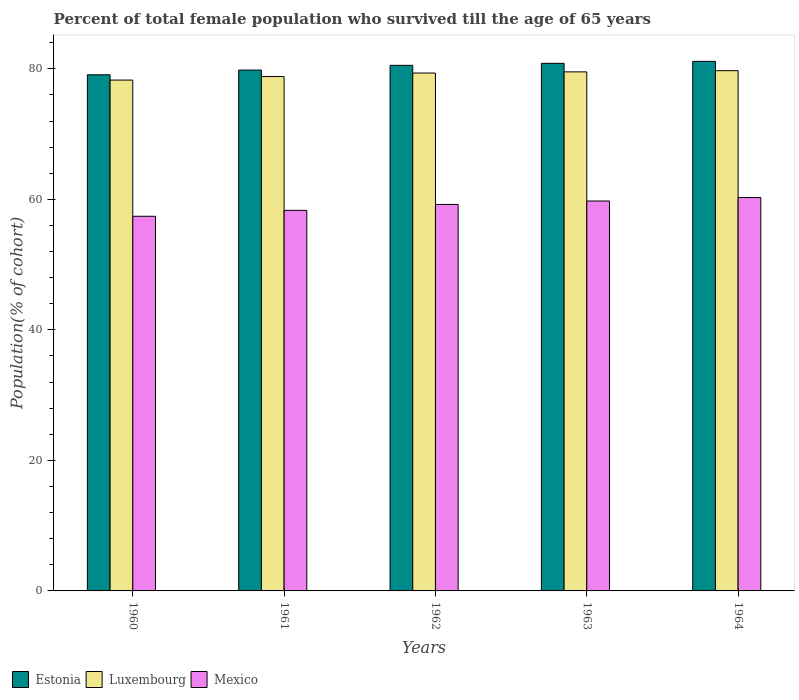Are the number of bars on each tick of the X-axis equal?
Provide a short and direct response. Yes. How many bars are there on the 1st tick from the left?
Provide a short and direct response. 3. How many bars are there on the 1st tick from the right?
Offer a terse response. 3. What is the label of the 1st group of bars from the left?
Your answer should be very brief. 1960. In how many cases, is the number of bars for a given year not equal to the number of legend labels?
Your response must be concise. 0. What is the percentage of total female population who survived till the age of 65 years in Mexico in 1964?
Give a very brief answer. 60.27. Across all years, what is the maximum percentage of total female population who survived till the age of 65 years in Mexico?
Your answer should be very brief. 60.27. Across all years, what is the minimum percentage of total female population who survived till the age of 65 years in Luxembourg?
Keep it short and to the point. 78.27. In which year was the percentage of total female population who survived till the age of 65 years in Estonia maximum?
Provide a short and direct response. 1964. What is the total percentage of total female population who survived till the age of 65 years in Estonia in the graph?
Offer a terse response. 401.4. What is the difference between the percentage of total female population who survived till the age of 65 years in Luxembourg in 1961 and that in 1963?
Keep it short and to the point. -0.72. What is the difference between the percentage of total female population who survived till the age of 65 years in Estonia in 1963 and the percentage of total female population who survived till the age of 65 years in Luxembourg in 1961?
Your response must be concise. 2.03. What is the average percentage of total female population who survived till the age of 65 years in Estonia per year?
Make the answer very short. 80.28. In the year 1961, what is the difference between the percentage of total female population who survived till the age of 65 years in Estonia and percentage of total female population who survived till the age of 65 years in Mexico?
Provide a succinct answer. 21.5. In how many years, is the percentage of total female population who survived till the age of 65 years in Mexico greater than 24 %?
Give a very brief answer. 5. What is the ratio of the percentage of total female population who survived till the age of 65 years in Estonia in 1960 to that in 1961?
Provide a short and direct response. 0.99. What is the difference between the highest and the second highest percentage of total female population who survived till the age of 65 years in Mexico?
Offer a terse response. 0.53. What is the difference between the highest and the lowest percentage of total female population who survived till the age of 65 years in Estonia?
Give a very brief answer. 2.06. Is the sum of the percentage of total female population who survived till the age of 65 years in Estonia in 1960 and 1962 greater than the maximum percentage of total female population who survived till the age of 65 years in Mexico across all years?
Your response must be concise. Yes. What does the 2nd bar from the left in 1961 represents?
Provide a short and direct response. Luxembourg. What does the 3rd bar from the right in 1960 represents?
Provide a short and direct response. Estonia. How many bars are there?
Make the answer very short. 15. How many years are there in the graph?
Ensure brevity in your answer.  5. Are the values on the major ticks of Y-axis written in scientific E-notation?
Your answer should be very brief. No. Does the graph contain grids?
Provide a succinct answer. No. Where does the legend appear in the graph?
Offer a terse response. Bottom left. How many legend labels are there?
Your response must be concise. 3. What is the title of the graph?
Offer a very short reply. Percent of total female population who survived till the age of 65 years. What is the label or title of the X-axis?
Your answer should be compact. Years. What is the label or title of the Y-axis?
Your answer should be very brief. Population(% of cohort). What is the Population(% of cohort) of Estonia in 1960?
Keep it short and to the point. 79.08. What is the Population(% of cohort) in Luxembourg in 1960?
Keep it short and to the point. 78.27. What is the Population(% of cohort) of Mexico in 1960?
Your response must be concise. 57.4. What is the Population(% of cohort) in Estonia in 1961?
Provide a short and direct response. 79.81. What is the Population(% of cohort) in Luxembourg in 1961?
Offer a very short reply. 78.81. What is the Population(% of cohort) in Mexico in 1961?
Your response must be concise. 58.31. What is the Population(% of cohort) in Estonia in 1962?
Your answer should be compact. 80.53. What is the Population(% of cohort) of Luxembourg in 1962?
Offer a very short reply. 79.35. What is the Population(% of cohort) in Mexico in 1962?
Your answer should be very brief. 59.22. What is the Population(% of cohort) in Estonia in 1963?
Offer a very short reply. 80.84. What is the Population(% of cohort) in Luxembourg in 1963?
Give a very brief answer. 79.53. What is the Population(% of cohort) in Mexico in 1963?
Offer a very short reply. 59.74. What is the Population(% of cohort) of Estonia in 1964?
Your answer should be compact. 81.14. What is the Population(% of cohort) of Luxembourg in 1964?
Your answer should be compact. 79.71. What is the Population(% of cohort) in Mexico in 1964?
Your answer should be compact. 60.27. Across all years, what is the maximum Population(% of cohort) of Estonia?
Give a very brief answer. 81.14. Across all years, what is the maximum Population(% of cohort) of Luxembourg?
Give a very brief answer. 79.71. Across all years, what is the maximum Population(% of cohort) of Mexico?
Offer a terse response. 60.27. Across all years, what is the minimum Population(% of cohort) in Estonia?
Your answer should be compact. 79.08. Across all years, what is the minimum Population(% of cohort) in Luxembourg?
Keep it short and to the point. 78.27. Across all years, what is the minimum Population(% of cohort) in Mexico?
Provide a short and direct response. 57.4. What is the total Population(% of cohort) in Estonia in the graph?
Keep it short and to the point. 401.4. What is the total Population(% of cohort) in Luxembourg in the graph?
Make the answer very short. 395.68. What is the total Population(% of cohort) in Mexico in the graph?
Your response must be concise. 294.94. What is the difference between the Population(% of cohort) of Estonia in 1960 and that in 1961?
Make the answer very short. -0.72. What is the difference between the Population(% of cohort) of Luxembourg in 1960 and that in 1961?
Keep it short and to the point. -0.54. What is the difference between the Population(% of cohort) in Mexico in 1960 and that in 1961?
Ensure brevity in your answer.  -0.91. What is the difference between the Population(% of cohort) in Estonia in 1960 and that in 1962?
Offer a terse response. -1.45. What is the difference between the Population(% of cohort) of Luxembourg in 1960 and that in 1962?
Ensure brevity in your answer.  -1.08. What is the difference between the Population(% of cohort) of Mexico in 1960 and that in 1962?
Ensure brevity in your answer.  -1.81. What is the difference between the Population(% of cohort) of Estonia in 1960 and that in 1963?
Ensure brevity in your answer.  -1.75. What is the difference between the Population(% of cohort) in Luxembourg in 1960 and that in 1963?
Keep it short and to the point. -1.26. What is the difference between the Population(% of cohort) in Mexico in 1960 and that in 1963?
Ensure brevity in your answer.  -2.34. What is the difference between the Population(% of cohort) of Estonia in 1960 and that in 1964?
Provide a succinct answer. -2.06. What is the difference between the Population(% of cohort) in Luxembourg in 1960 and that in 1964?
Offer a very short reply. -1.44. What is the difference between the Population(% of cohort) of Mexico in 1960 and that in 1964?
Offer a very short reply. -2.87. What is the difference between the Population(% of cohort) of Estonia in 1961 and that in 1962?
Your response must be concise. -0.72. What is the difference between the Population(% of cohort) of Luxembourg in 1961 and that in 1962?
Give a very brief answer. -0.54. What is the difference between the Population(% of cohort) of Mexico in 1961 and that in 1962?
Offer a terse response. -0.91. What is the difference between the Population(% of cohort) of Estonia in 1961 and that in 1963?
Give a very brief answer. -1.03. What is the difference between the Population(% of cohort) of Luxembourg in 1961 and that in 1963?
Your answer should be compact. -0.72. What is the difference between the Population(% of cohort) of Mexico in 1961 and that in 1963?
Keep it short and to the point. -1.43. What is the difference between the Population(% of cohort) in Estonia in 1961 and that in 1964?
Keep it short and to the point. -1.33. What is the difference between the Population(% of cohort) in Luxembourg in 1961 and that in 1964?
Give a very brief answer. -0.9. What is the difference between the Population(% of cohort) of Mexico in 1961 and that in 1964?
Offer a terse response. -1.96. What is the difference between the Population(% of cohort) in Estonia in 1962 and that in 1963?
Keep it short and to the point. -0.31. What is the difference between the Population(% of cohort) of Luxembourg in 1962 and that in 1963?
Provide a short and direct response. -0.18. What is the difference between the Population(% of cohort) of Mexico in 1962 and that in 1963?
Keep it short and to the point. -0.53. What is the difference between the Population(% of cohort) of Estonia in 1962 and that in 1964?
Provide a succinct answer. -0.61. What is the difference between the Population(% of cohort) of Luxembourg in 1962 and that in 1964?
Your answer should be compact. -0.36. What is the difference between the Population(% of cohort) in Mexico in 1962 and that in 1964?
Keep it short and to the point. -1.06. What is the difference between the Population(% of cohort) of Estonia in 1963 and that in 1964?
Make the answer very short. -0.31. What is the difference between the Population(% of cohort) in Luxembourg in 1963 and that in 1964?
Offer a terse response. -0.18. What is the difference between the Population(% of cohort) in Mexico in 1963 and that in 1964?
Ensure brevity in your answer.  -0.53. What is the difference between the Population(% of cohort) in Estonia in 1960 and the Population(% of cohort) in Luxembourg in 1961?
Give a very brief answer. 0.27. What is the difference between the Population(% of cohort) in Estonia in 1960 and the Population(% of cohort) in Mexico in 1961?
Keep it short and to the point. 20.77. What is the difference between the Population(% of cohort) of Luxembourg in 1960 and the Population(% of cohort) of Mexico in 1961?
Your answer should be compact. 19.96. What is the difference between the Population(% of cohort) in Estonia in 1960 and the Population(% of cohort) in Luxembourg in 1962?
Offer a terse response. -0.27. What is the difference between the Population(% of cohort) of Estonia in 1960 and the Population(% of cohort) of Mexico in 1962?
Keep it short and to the point. 19.87. What is the difference between the Population(% of cohort) of Luxembourg in 1960 and the Population(% of cohort) of Mexico in 1962?
Ensure brevity in your answer.  19.06. What is the difference between the Population(% of cohort) in Estonia in 1960 and the Population(% of cohort) in Luxembourg in 1963?
Your answer should be compact. -0.45. What is the difference between the Population(% of cohort) of Estonia in 1960 and the Population(% of cohort) of Mexico in 1963?
Give a very brief answer. 19.34. What is the difference between the Population(% of cohort) of Luxembourg in 1960 and the Population(% of cohort) of Mexico in 1963?
Keep it short and to the point. 18.53. What is the difference between the Population(% of cohort) in Estonia in 1960 and the Population(% of cohort) in Luxembourg in 1964?
Offer a terse response. -0.63. What is the difference between the Population(% of cohort) of Estonia in 1960 and the Population(% of cohort) of Mexico in 1964?
Provide a short and direct response. 18.81. What is the difference between the Population(% of cohort) of Luxembourg in 1960 and the Population(% of cohort) of Mexico in 1964?
Provide a succinct answer. 18. What is the difference between the Population(% of cohort) in Estonia in 1961 and the Population(% of cohort) in Luxembourg in 1962?
Give a very brief answer. 0.46. What is the difference between the Population(% of cohort) in Estonia in 1961 and the Population(% of cohort) in Mexico in 1962?
Your response must be concise. 20.59. What is the difference between the Population(% of cohort) of Luxembourg in 1961 and the Population(% of cohort) of Mexico in 1962?
Provide a succinct answer. 19.6. What is the difference between the Population(% of cohort) of Estonia in 1961 and the Population(% of cohort) of Luxembourg in 1963?
Make the answer very short. 0.28. What is the difference between the Population(% of cohort) in Estonia in 1961 and the Population(% of cohort) in Mexico in 1963?
Offer a terse response. 20.06. What is the difference between the Population(% of cohort) in Luxembourg in 1961 and the Population(% of cohort) in Mexico in 1963?
Offer a terse response. 19.07. What is the difference between the Population(% of cohort) of Estonia in 1961 and the Population(% of cohort) of Luxembourg in 1964?
Offer a very short reply. 0.09. What is the difference between the Population(% of cohort) in Estonia in 1961 and the Population(% of cohort) in Mexico in 1964?
Offer a very short reply. 19.53. What is the difference between the Population(% of cohort) in Luxembourg in 1961 and the Population(% of cohort) in Mexico in 1964?
Provide a short and direct response. 18.54. What is the difference between the Population(% of cohort) of Estonia in 1962 and the Population(% of cohort) of Luxembourg in 1963?
Provide a short and direct response. 1. What is the difference between the Population(% of cohort) of Estonia in 1962 and the Population(% of cohort) of Mexico in 1963?
Your answer should be very brief. 20.79. What is the difference between the Population(% of cohort) in Luxembourg in 1962 and the Population(% of cohort) in Mexico in 1963?
Provide a short and direct response. 19.61. What is the difference between the Population(% of cohort) of Estonia in 1962 and the Population(% of cohort) of Luxembourg in 1964?
Provide a short and direct response. 0.82. What is the difference between the Population(% of cohort) in Estonia in 1962 and the Population(% of cohort) in Mexico in 1964?
Your answer should be very brief. 20.26. What is the difference between the Population(% of cohort) of Luxembourg in 1962 and the Population(% of cohort) of Mexico in 1964?
Provide a short and direct response. 19.08. What is the difference between the Population(% of cohort) of Estonia in 1963 and the Population(% of cohort) of Luxembourg in 1964?
Offer a terse response. 1.12. What is the difference between the Population(% of cohort) in Estonia in 1963 and the Population(% of cohort) in Mexico in 1964?
Your response must be concise. 20.56. What is the difference between the Population(% of cohort) in Luxembourg in 1963 and the Population(% of cohort) in Mexico in 1964?
Ensure brevity in your answer.  19.26. What is the average Population(% of cohort) in Estonia per year?
Provide a short and direct response. 80.28. What is the average Population(% of cohort) in Luxembourg per year?
Your response must be concise. 79.14. What is the average Population(% of cohort) in Mexico per year?
Your answer should be very brief. 58.99. In the year 1960, what is the difference between the Population(% of cohort) of Estonia and Population(% of cohort) of Luxembourg?
Offer a very short reply. 0.81. In the year 1960, what is the difference between the Population(% of cohort) in Estonia and Population(% of cohort) in Mexico?
Offer a terse response. 21.68. In the year 1960, what is the difference between the Population(% of cohort) in Luxembourg and Population(% of cohort) in Mexico?
Ensure brevity in your answer.  20.87. In the year 1961, what is the difference between the Population(% of cohort) in Estonia and Population(% of cohort) in Luxembourg?
Your answer should be compact. 1. In the year 1961, what is the difference between the Population(% of cohort) of Estonia and Population(% of cohort) of Mexico?
Ensure brevity in your answer.  21.5. In the year 1961, what is the difference between the Population(% of cohort) in Luxembourg and Population(% of cohort) in Mexico?
Keep it short and to the point. 20.5. In the year 1962, what is the difference between the Population(% of cohort) of Estonia and Population(% of cohort) of Luxembourg?
Your answer should be compact. 1.18. In the year 1962, what is the difference between the Population(% of cohort) in Estonia and Population(% of cohort) in Mexico?
Your response must be concise. 21.32. In the year 1962, what is the difference between the Population(% of cohort) in Luxembourg and Population(% of cohort) in Mexico?
Offer a very short reply. 20.14. In the year 1963, what is the difference between the Population(% of cohort) of Estonia and Population(% of cohort) of Luxembourg?
Offer a terse response. 1.31. In the year 1963, what is the difference between the Population(% of cohort) in Estonia and Population(% of cohort) in Mexico?
Provide a succinct answer. 21.09. In the year 1963, what is the difference between the Population(% of cohort) in Luxembourg and Population(% of cohort) in Mexico?
Ensure brevity in your answer.  19.79. In the year 1964, what is the difference between the Population(% of cohort) in Estonia and Population(% of cohort) in Luxembourg?
Make the answer very short. 1.43. In the year 1964, what is the difference between the Population(% of cohort) of Estonia and Population(% of cohort) of Mexico?
Give a very brief answer. 20.87. In the year 1964, what is the difference between the Population(% of cohort) in Luxembourg and Population(% of cohort) in Mexico?
Your answer should be very brief. 19.44. What is the ratio of the Population(% of cohort) in Estonia in 1960 to that in 1961?
Offer a terse response. 0.99. What is the ratio of the Population(% of cohort) of Luxembourg in 1960 to that in 1961?
Your response must be concise. 0.99. What is the ratio of the Population(% of cohort) of Mexico in 1960 to that in 1961?
Keep it short and to the point. 0.98. What is the ratio of the Population(% of cohort) of Luxembourg in 1960 to that in 1962?
Offer a terse response. 0.99. What is the ratio of the Population(% of cohort) in Mexico in 1960 to that in 1962?
Offer a terse response. 0.97. What is the ratio of the Population(% of cohort) in Estonia in 1960 to that in 1963?
Offer a very short reply. 0.98. What is the ratio of the Population(% of cohort) in Luxembourg in 1960 to that in 1963?
Offer a very short reply. 0.98. What is the ratio of the Population(% of cohort) in Mexico in 1960 to that in 1963?
Your answer should be very brief. 0.96. What is the ratio of the Population(% of cohort) of Estonia in 1960 to that in 1964?
Your answer should be very brief. 0.97. What is the ratio of the Population(% of cohort) of Luxembourg in 1960 to that in 1964?
Provide a short and direct response. 0.98. What is the ratio of the Population(% of cohort) of Mexico in 1960 to that in 1964?
Your response must be concise. 0.95. What is the ratio of the Population(% of cohort) in Estonia in 1961 to that in 1962?
Give a very brief answer. 0.99. What is the ratio of the Population(% of cohort) of Mexico in 1961 to that in 1962?
Give a very brief answer. 0.98. What is the ratio of the Population(% of cohort) in Estonia in 1961 to that in 1963?
Your response must be concise. 0.99. What is the ratio of the Population(% of cohort) in Luxembourg in 1961 to that in 1963?
Your answer should be compact. 0.99. What is the ratio of the Population(% of cohort) of Mexico in 1961 to that in 1963?
Offer a terse response. 0.98. What is the ratio of the Population(% of cohort) in Estonia in 1961 to that in 1964?
Your answer should be compact. 0.98. What is the ratio of the Population(% of cohort) of Luxembourg in 1961 to that in 1964?
Provide a succinct answer. 0.99. What is the ratio of the Population(% of cohort) of Mexico in 1961 to that in 1964?
Your response must be concise. 0.97. What is the ratio of the Population(% of cohort) of Mexico in 1962 to that in 1963?
Your response must be concise. 0.99. What is the ratio of the Population(% of cohort) in Mexico in 1962 to that in 1964?
Give a very brief answer. 0.98. What is the ratio of the Population(% of cohort) of Estonia in 1963 to that in 1964?
Your response must be concise. 1. What is the ratio of the Population(% of cohort) of Luxembourg in 1963 to that in 1964?
Keep it short and to the point. 1. What is the ratio of the Population(% of cohort) of Mexico in 1963 to that in 1964?
Your answer should be very brief. 0.99. What is the difference between the highest and the second highest Population(% of cohort) of Estonia?
Your response must be concise. 0.31. What is the difference between the highest and the second highest Population(% of cohort) of Luxembourg?
Your answer should be very brief. 0.18. What is the difference between the highest and the second highest Population(% of cohort) of Mexico?
Keep it short and to the point. 0.53. What is the difference between the highest and the lowest Population(% of cohort) of Estonia?
Ensure brevity in your answer.  2.06. What is the difference between the highest and the lowest Population(% of cohort) in Luxembourg?
Your answer should be compact. 1.44. What is the difference between the highest and the lowest Population(% of cohort) of Mexico?
Provide a succinct answer. 2.87. 